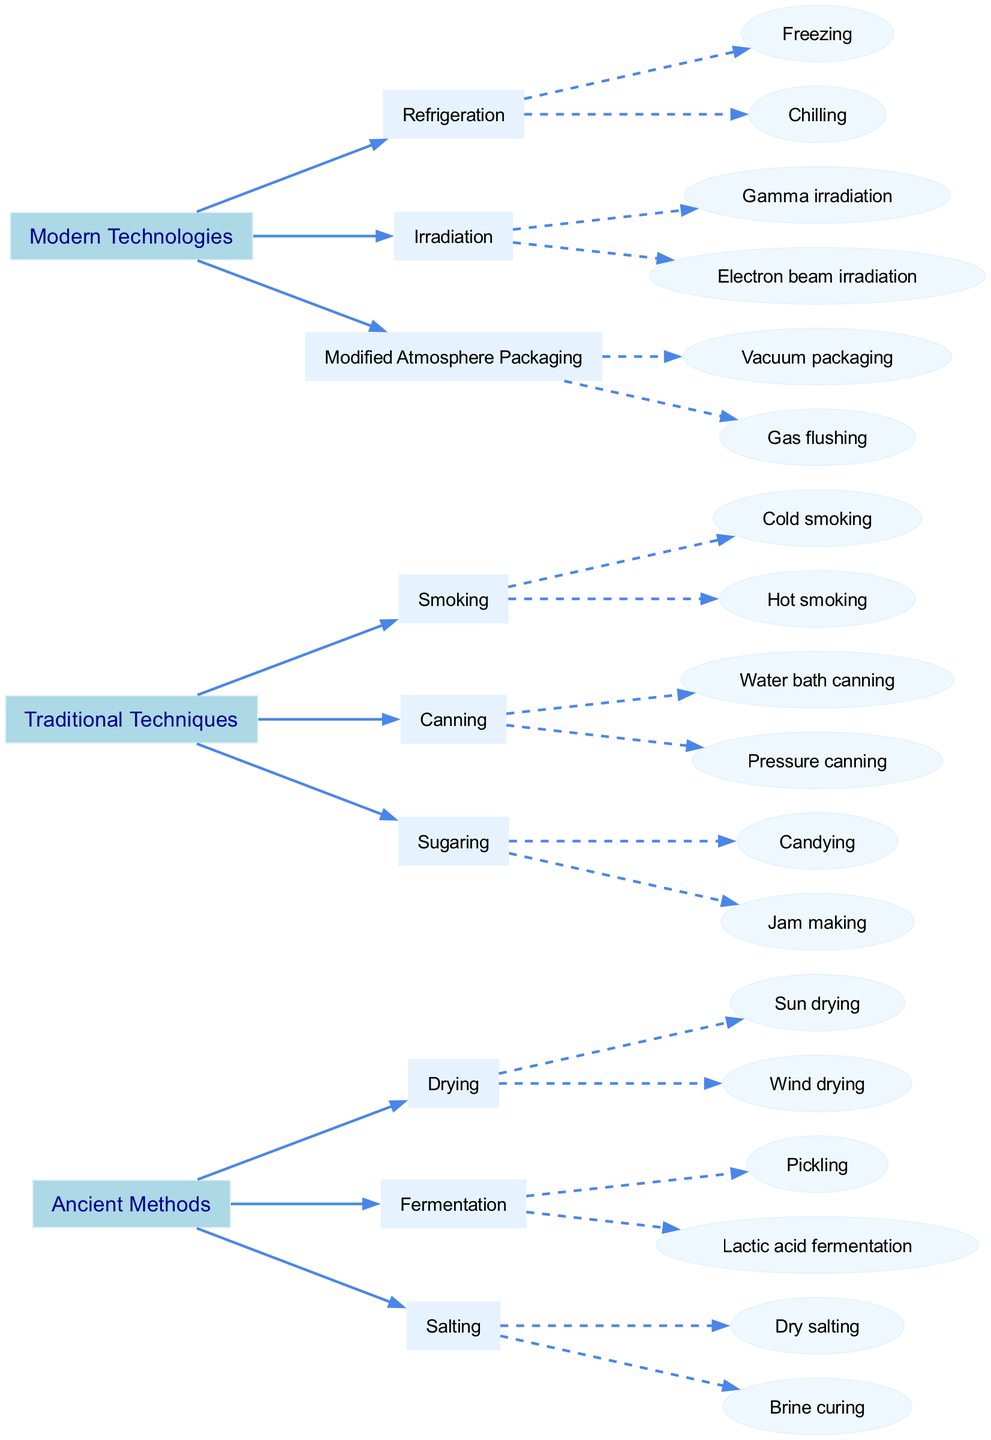What are the three main categories of food preservation techniques? The diagram shows three main categories: Ancient Methods, Traditional Techniques, and Modern Technologies.
Answer: Ancient Methods, Traditional Techniques, Modern Technologies How many sub-techniques are listed under Fermentation? Under the Fermentation technique, there are two sub-techniques: Pickling and Lactic acid fermentation. Counting these gives a total of 2 sub-techniques.
Answer: 2 What technique is a form of modern technology used for food preservation? In the diagram, Refrigeration is a listed technique under Modern Technologies, showing that it's a contemporary method used for preserving food.
Answer: Refrigeration Which preservation technique involves using salt? Salting is the primary technique that involves the use of salt as per the diagram. This technique is specifically categorized under Ancient Methods.
Answer: Salting What technique has both cold and hot variations? The Smoking technique includes both Cold smoking and Hot smoking as its sub-techniques, which are detailed in the Traditional Techniques section of the diagram.
Answer: Smoking What is one modern method of packaging food? Modified Atmosphere Packaging includes both Vacuum packaging and Gas flushing, captured under the Modern Technologies category.
Answer: Modified Atmosphere Packaging Which ancient preservation technique has a sub-technique called Brine curing? The Salting technique in the Ancient Methods has a sub-technique known as Brine curing, making it an important method tied to the use of salt for preservation.
Answer: Salting What sub-technique is associated with Lactic acid fermentation? Lactic acid fermentation falls under the broader technique of Fermentation, which is one of the Ancient Methods.
Answer: Lactic acid fermentation How many sub-techniques are listed under Canning? The Canning technique has two sub-techniques specified in the diagram: Water bath canning and Pressure canning. Counting these gives a total of 2 sub-techniques.
Answer: 2 